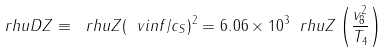Convert formula to latex. <formula><loc_0><loc_0><loc_500><loc_500>\ r h u D Z \equiv \ r h u Z ( \ v i n f / c _ { S } ) ^ { 2 } = 6 . 0 6 \times 1 0 ^ { 3 } \ r h u Z \left ( \frac { v _ { 8 } ^ { 2 } } { T _ { 4 } } \right )</formula> 